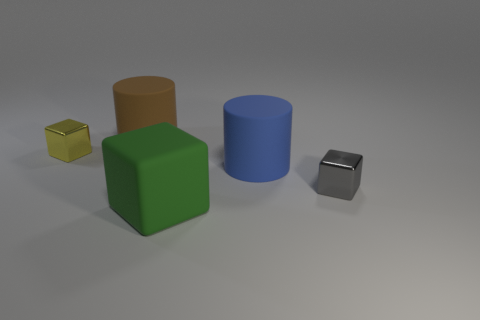Add 2 blocks. How many objects exist? 7 Subtract all yellow cubes. How many cubes are left? 2 Subtract all blue cylinders. How many cylinders are left? 1 Subtract all blocks. How many objects are left? 2 Subtract 2 blocks. How many blocks are left? 1 Add 4 large green blocks. How many large green blocks are left? 5 Add 1 gray things. How many gray things exist? 2 Subtract 0 purple cubes. How many objects are left? 5 Subtract all red cylinders. Subtract all blue balls. How many cylinders are left? 2 Subtract all yellow cubes. How many brown cylinders are left? 1 